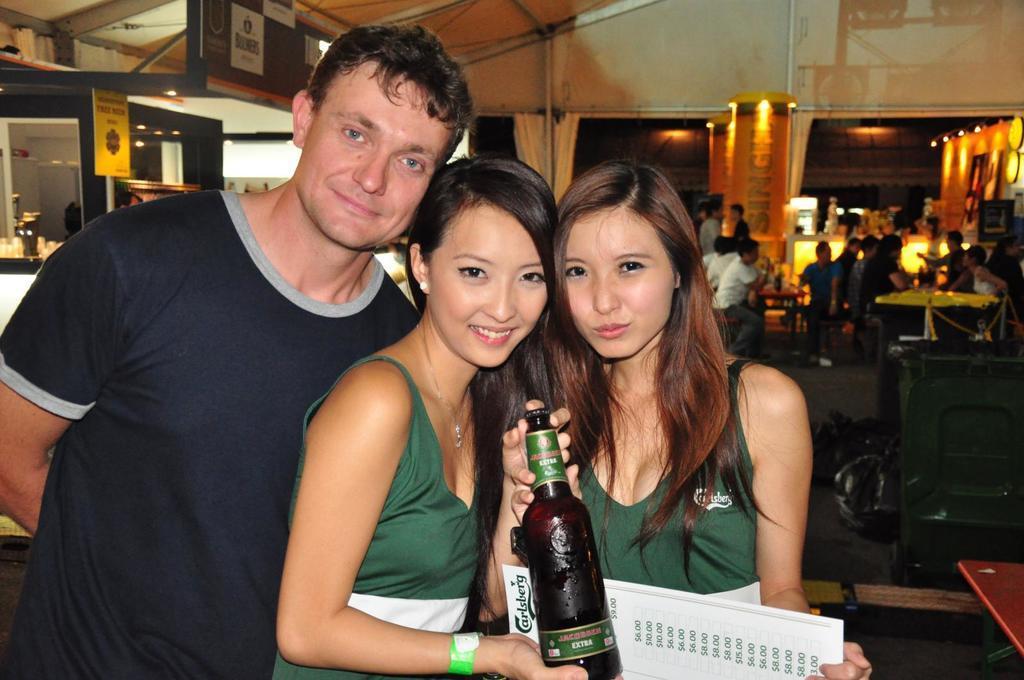How would you summarize this image in a sentence or two? In this image we can see two women wearing green dress are holding a bottle in their hands. We can see a man standing beside them. In the background we can see many people sitting near the tables. 